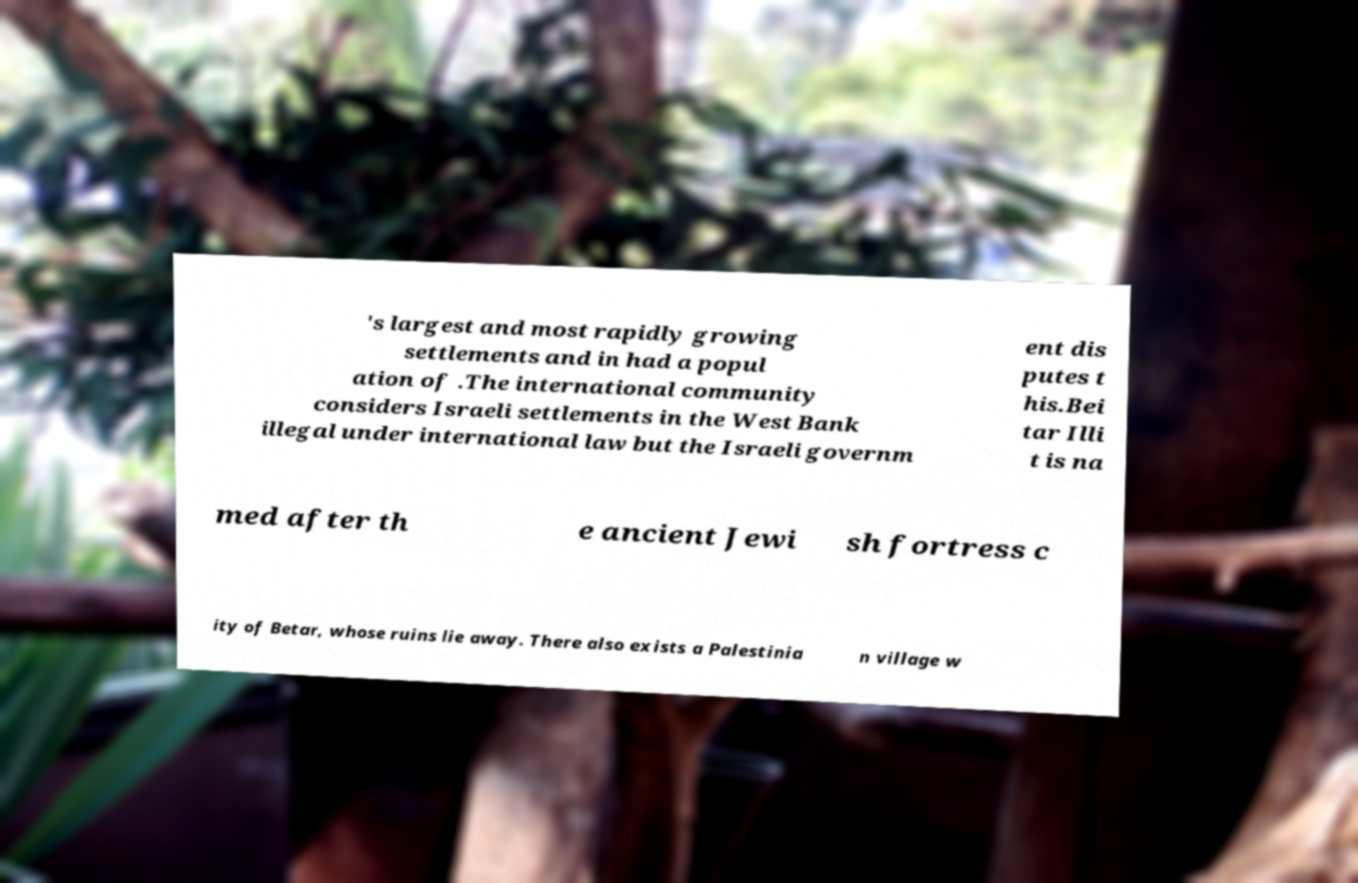Please read and relay the text visible in this image. What does it say? 's largest and most rapidly growing settlements and in had a popul ation of .The international community considers Israeli settlements in the West Bank illegal under international law but the Israeli governm ent dis putes t his.Bei tar Illi t is na med after th e ancient Jewi sh fortress c ity of Betar, whose ruins lie away. There also exists a Palestinia n village w 